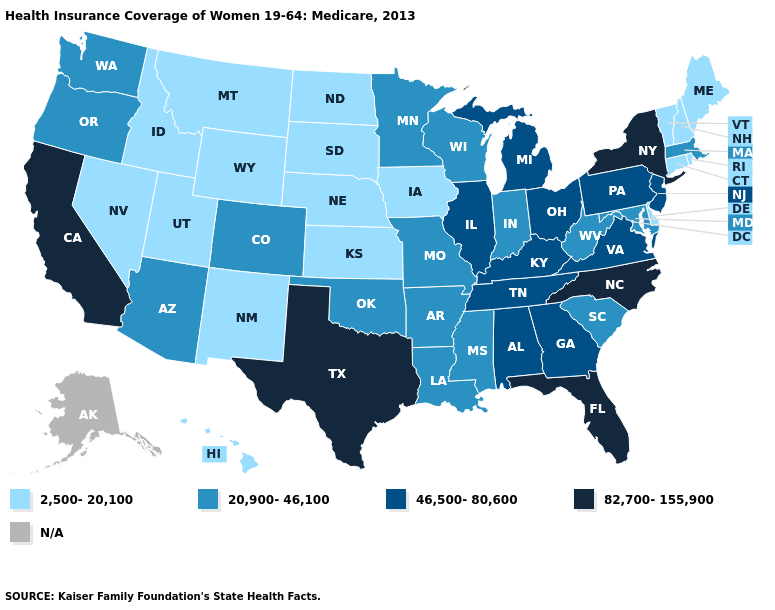Name the states that have a value in the range 20,900-46,100?
Concise answer only. Arizona, Arkansas, Colorado, Indiana, Louisiana, Maryland, Massachusetts, Minnesota, Mississippi, Missouri, Oklahoma, Oregon, South Carolina, Washington, West Virginia, Wisconsin. Which states hav the highest value in the MidWest?
Write a very short answer. Illinois, Michigan, Ohio. Name the states that have a value in the range N/A?
Concise answer only. Alaska. Does Indiana have the lowest value in the USA?
Write a very short answer. No. What is the value of Mississippi?
Give a very brief answer. 20,900-46,100. Name the states that have a value in the range 46,500-80,600?
Keep it brief. Alabama, Georgia, Illinois, Kentucky, Michigan, New Jersey, Ohio, Pennsylvania, Tennessee, Virginia. What is the value of Minnesota?
Concise answer only. 20,900-46,100. Name the states that have a value in the range 82,700-155,900?
Give a very brief answer. California, Florida, New York, North Carolina, Texas. What is the highest value in the West ?
Short answer required. 82,700-155,900. How many symbols are there in the legend?
Be succinct. 5. What is the value of Delaware?
Concise answer only. 2,500-20,100. Does New York have the highest value in the USA?
Give a very brief answer. Yes. What is the value of Minnesota?
Short answer required. 20,900-46,100. Does the first symbol in the legend represent the smallest category?
Give a very brief answer. Yes. Which states have the highest value in the USA?
Answer briefly. California, Florida, New York, North Carolina, Texas. 